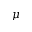Convert formula to latex. <formula><loc_0><loc_0><loc_500><loc_500>\mu</formula> 